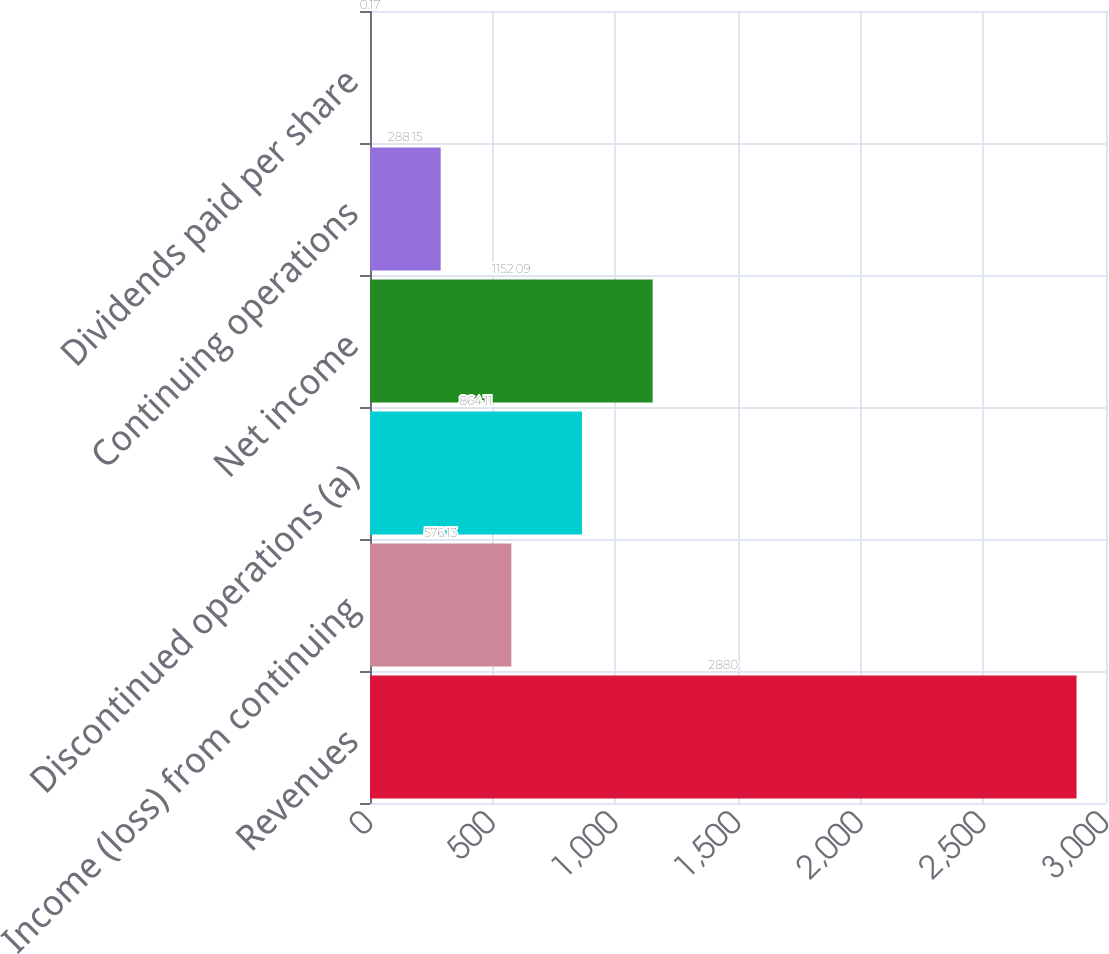Convert chart to OTSL. <chart><loc_0><loc_0><loc_500><loc_500><bar_chart><fcel>Revenues<fcel>Income (loss) from continuing<fcel>Discontinued operations (a)<fcel>Net income<fcel>Continuing operations<fcel>Dividends paid per share<nl><fcel>2880<fcel>576.13<fcel>864.11<fcel>1152.09<fcel>288.15<fcel>0.17<nl></chart> 